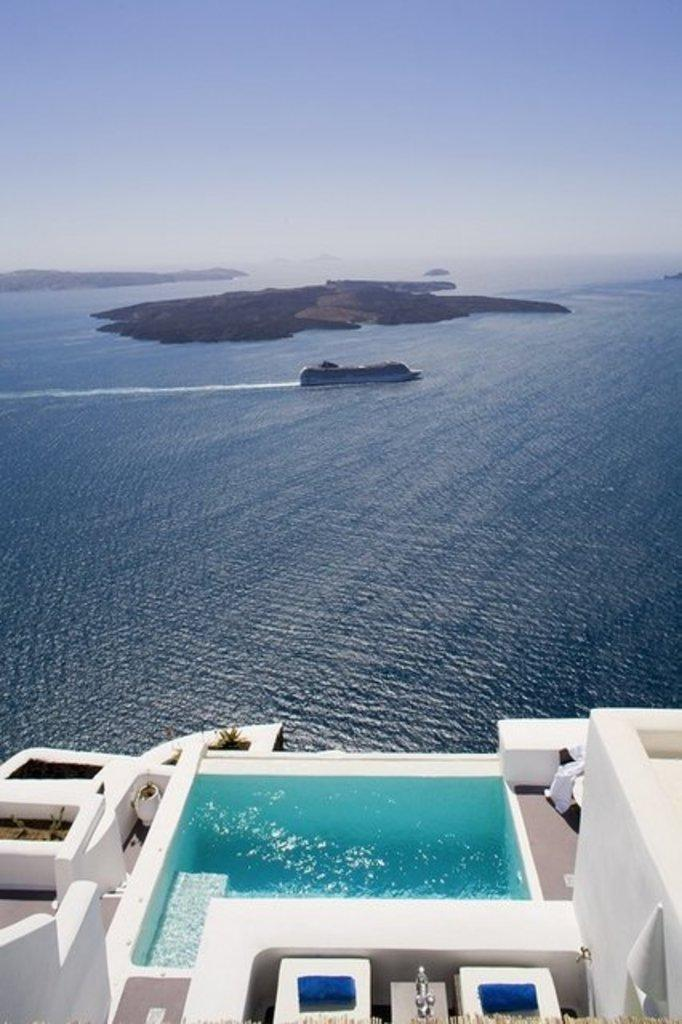What is the main subject of the image? The main subject of the image is a ship sailing in the water. Can you describe the surrounding environment? There is land visible between the water, and there is a building with a pool on top of it. How many trucks are parked near the jail in the image? There is no jail or trucks present in the image. 